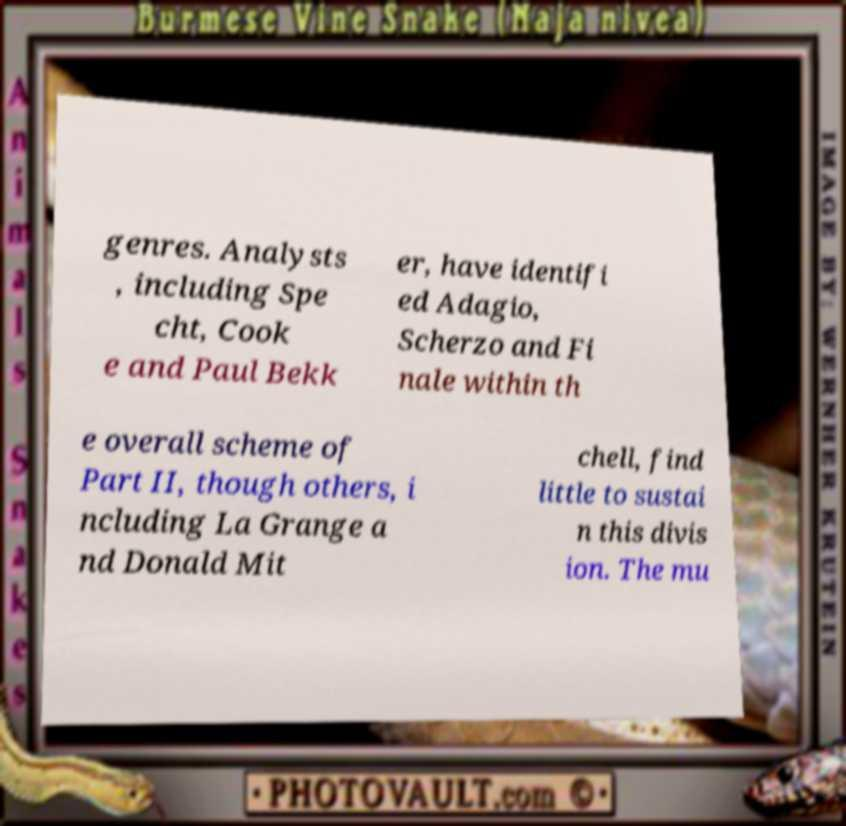I need the written content from this picture converted into text. Can you do that? genres. Analysts , including Spe cht, Cook e and Paul Bekk er, have identifi ed Adagio, Scherzo and Fi nale within th e overall scheme of Part II, though others, i ncluding La Grange a nd Donald Mit chell, find little to sustai n this divis ion. The mu 